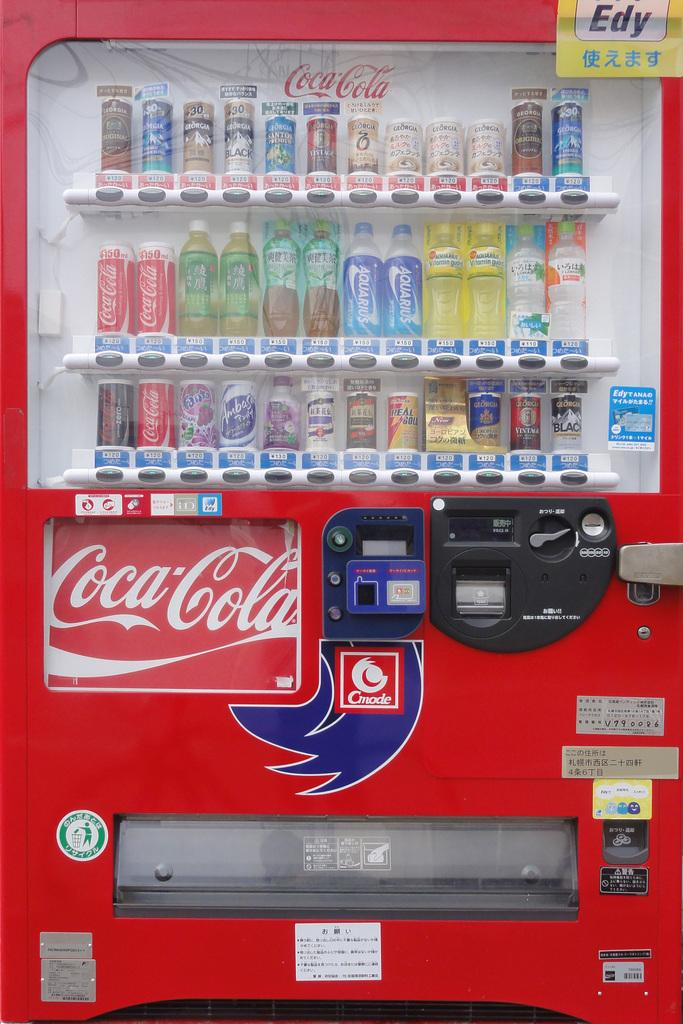What type of vending machine is in the image? There is a Coca-Cola vending machine in the image. How are the bottles arranged in the machine? The bottles are arranged behind the glass at the top of the machine. What additional features can be seen on the vending machine? There are posts attached to the machine at the bottom. What type of verse is written on the vending machine in the image? There is no verse written on the vending machine in the image. 